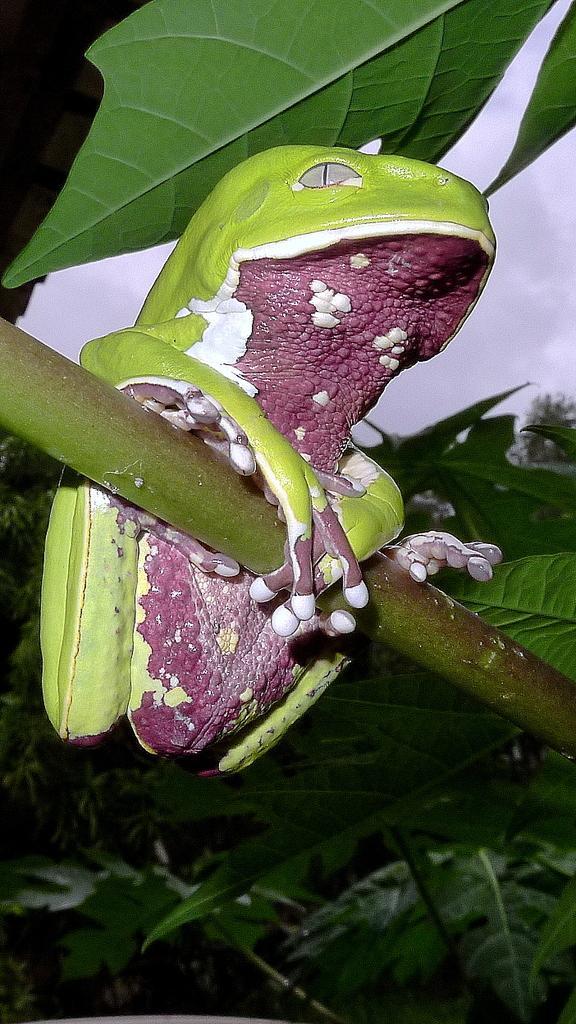Describe this image in one or two sentences. In this image there is a frog toy on the tree stem. At the top there are green leaves. 